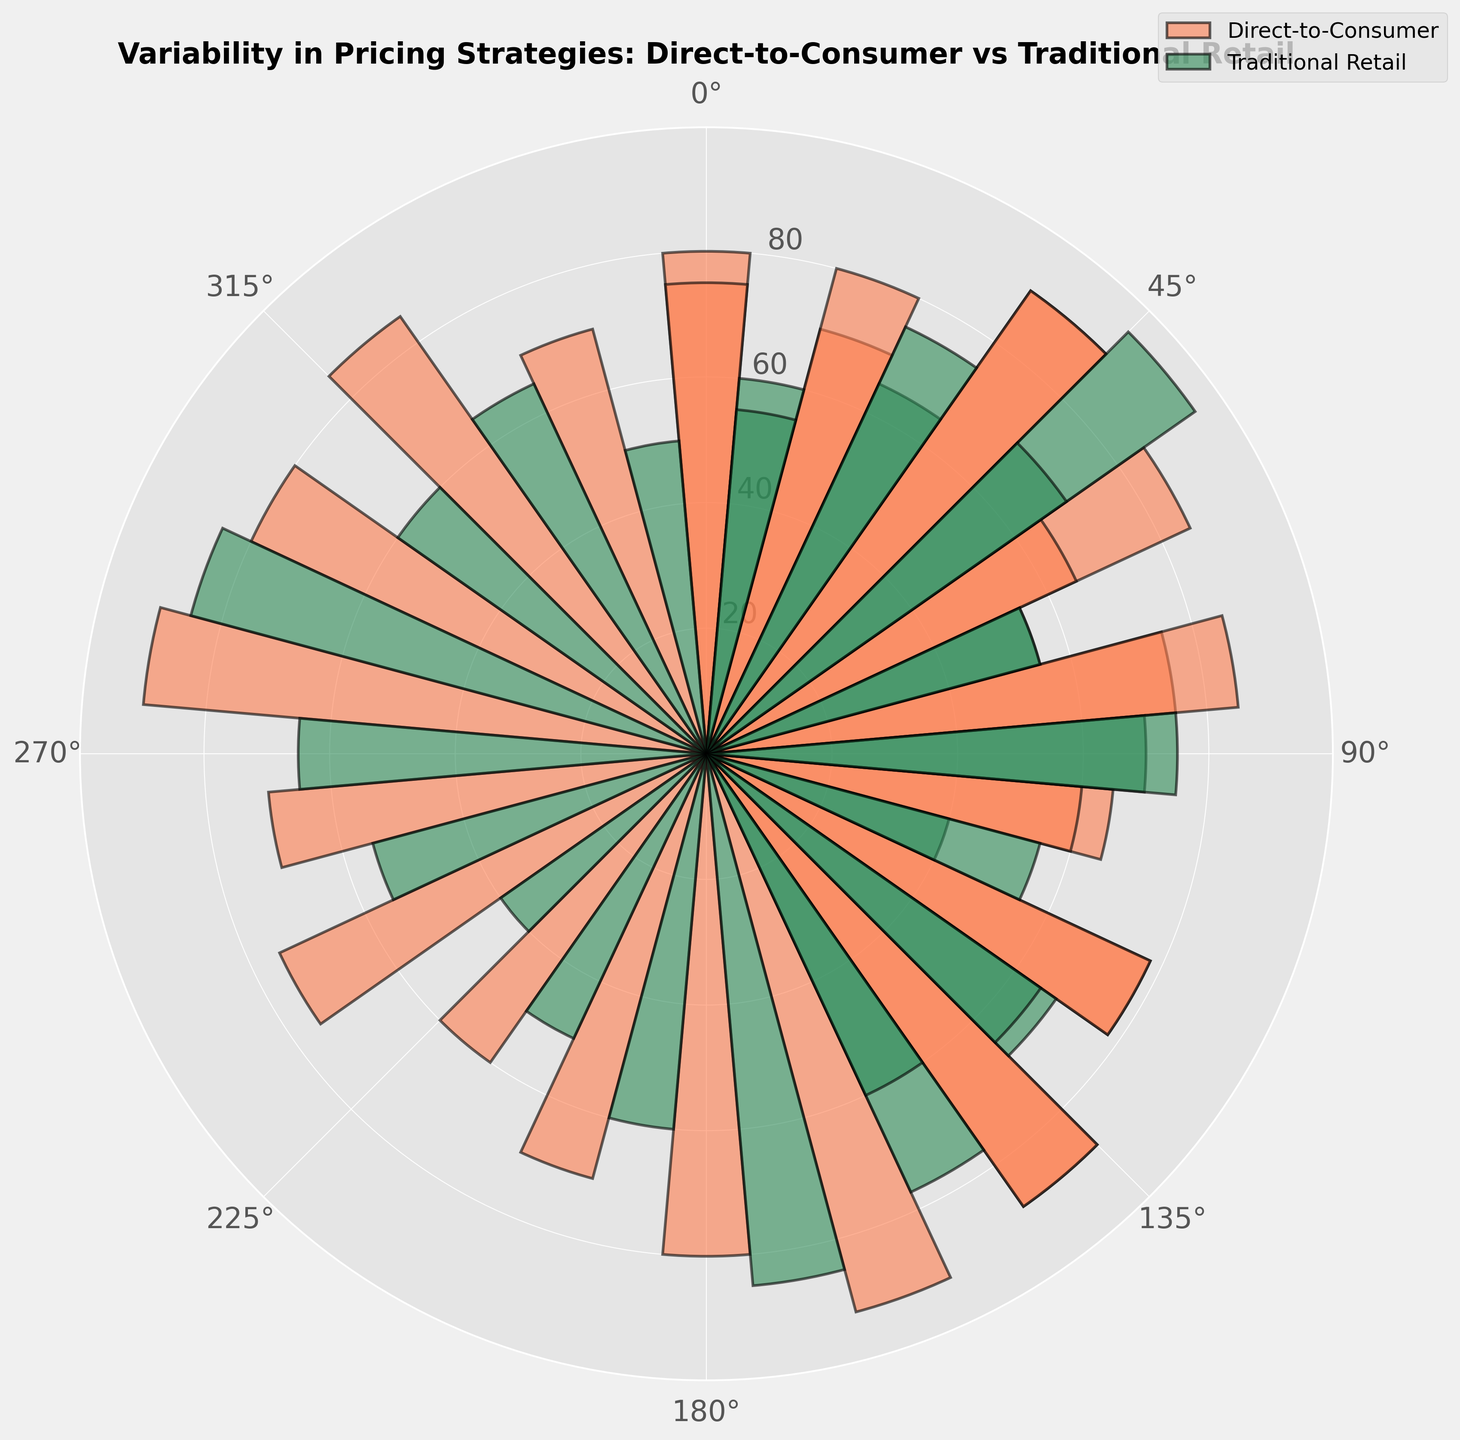What is the value of the highest bar for direct-to-consumer brands? Look at the direct-to-consumer (coral-colored) bars and identify the tallest one, which corresponds to the value of 92 at an angle of 160 degrees.
Answer: 92 Which pricing strategy shows a greater difference in value between direct-to-consumer and traditional retail channels for electronics? Compare the differences in values for all pricing strategies in the electronics category. For low price strategy, the difference is 78 - 68 = 10. For medium price strategy, the difference is 70 - 65 = 5. For dynamic pricing, the difference is 65 - 55 = 10. For premium pricing, the difference is 85 - 65 = 20. For subscription model, the difference is 60 - 40 = 20. The greatest differences are observed in the premium pricing and subscription model strategies.
Answer: Premium Pricing and Subscription Model Which category has the highest average value for direct-to-consumer pricing strategies, and what is that average? Calculate the sum and then the average for each category in direct-to-consumer brands: 
- Apparel: (80 + 65 + 70 + 88) / 4 = 75.75
- Electronics: (70 + 78 + 60 + 85) / 4 = 73.25
- Beauty: (90 + 88 + 75 + 85 + 70) / 5 = 81.6
- Footwear: (85 + 92 + 70 + 75 + 60) / 5 = 76.4
- Home Goods: (75 + 80 + 90 + 78) / 4 = 80.75 
The highest average is in the Beauty category.
Answer: Beauty, 81.6 Is there a pricing strategy where direct-to-consumer always has higher values than traditional retail across all categories? Compare the values of each pricing strategy for both channels across all categories:
- Low Price Strategy: Higher in all categories except beauty
- Medium Price Strategy: Higher in all categories
- High Price Strategy: Higher in all categories
- Dynamic Pricing: Higher in all categories except electronics
- Premium Pricing: Higher in all categories
- Subscription Model: Higher in all categories
The strategies where direct-to-consumer always has higher values are medium price strategy, high price strategy, premium pricing, and subscription model.
Answer: Medium Price Strategy, High Price Strategy, Premium Pricing, Subscription Model What is the total combined value for direct-to-consumer and traditional retail brands utilizing dynamic pricing? Sum all values for dynamic pricing strategy across both channels (85 + 55 + 80 + 60 + 65 + 55) = 400
Answer: 400 